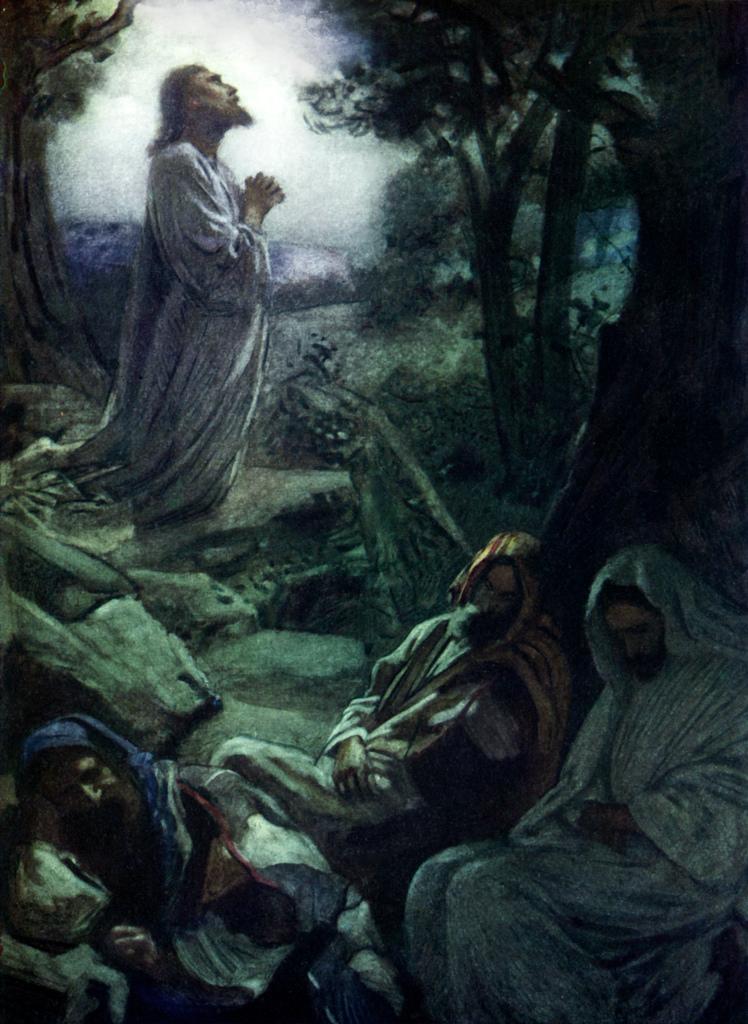How would you summarize this image in a sentence or two? In this image I can see depiction picture of people and of trees. 